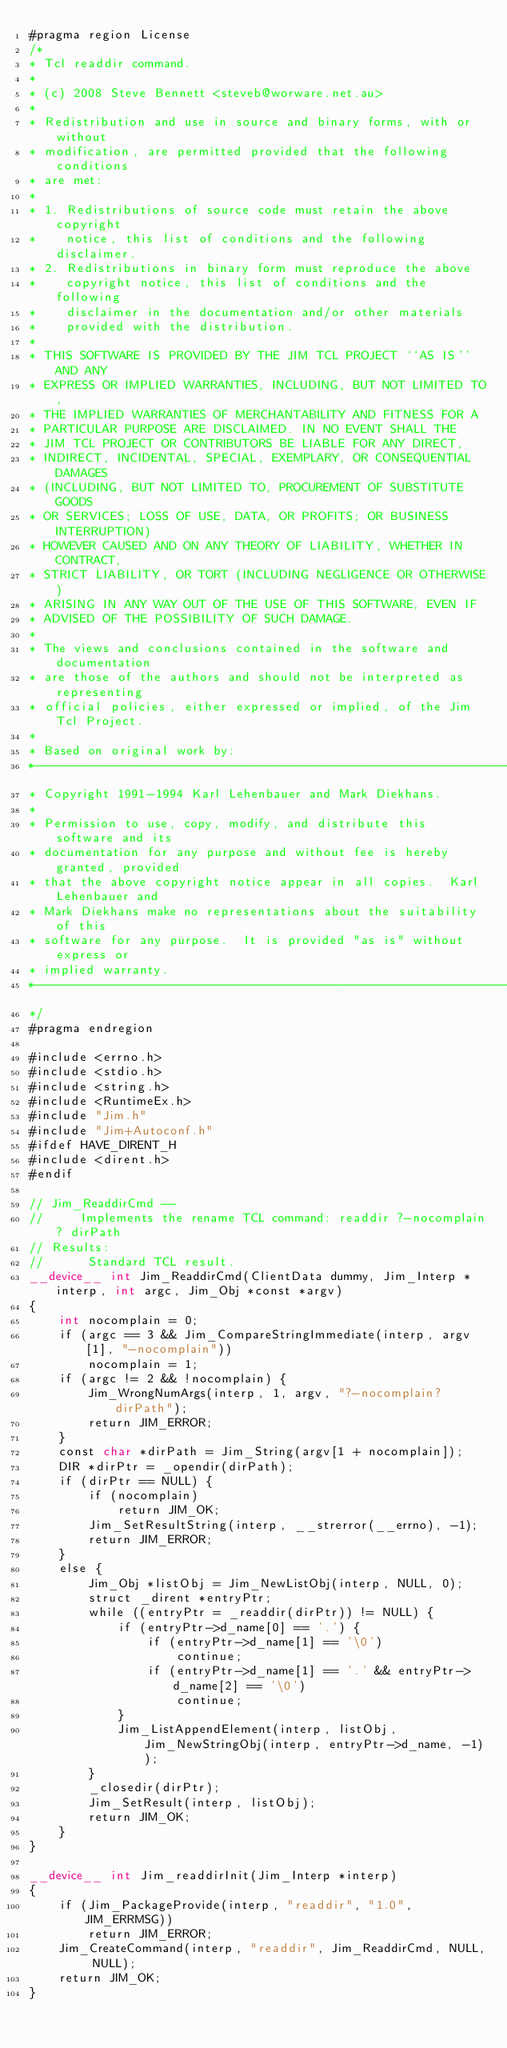Convert code to text. <code><loc_0><loc_0><loc_500><loc_500><_Cuda_>#pragma region License
/*
* Tcl readdir command.
*
* (c) 2008 Steve Bennett <steveb@worware.net.au>
*
* Redistribution and use in source and binary forms, with or without
* modification, are permitted provided that the following conditions
* are met:
*
* 1. Redistributions of source code must retain the above copyright
*    notice, this list of conditions and the following disclaimer.
* 2. Redistributions in binary form must reproduce the above
*    copyright notice, this list of conditions and the following
*    disclaimer in the documentation and/or other materials
*    provided with the distribution.
*
* THIS SOFTWARE IS PROVIDED BY THE JIM TCL PROJECT ``AS IS'' AND ANY
* EXPRESS OR IMPLIED WARRANTIES, INCLUDING, BUT NOT LIMITED TO,
* THE IMPLIED WARRANTIES OF MERCHANTABILITY AND FITNESS FOR A
* PARTICULAR PURPOSE ARE DISCLAIMED. IN NO EVENT SHALL THE
* JIM TCL PROJECT OR CONTRIBUTORS BE LIABLE FOR ANY DIRECT,
* INDIRECT, INCIDENTAL, SPECIAL, EXEMPLARY, OR CONSEQUENTIAL DAMAGES
* (INCLUDING, BUT NOT LIMITED TO, PROCUREMENT OF SUBSTITUTE GOODS
* OR SERVICES; LOSS OF USE, DATA, OR PROFITS; OR BUSINESS INTERRUPTION)
* HOWEVER CAUSED AND ON ANY THEORY OF LIABILITY, WHETHER IN CONTRACT,
* STRICT LIABILITY, OR TORT (INCLUDING NEGLIGENCE OR OTHERWISE)
* ARISING IN ANY WAY OUT OF THE USE OF THIS SOFTWARE, EVEN IF
* ADVISED OF THE POSSIBILITY OF SUCH DAMAGE.
*
* The views and conclusions contained in the software and documentation
* are those of the authors and should not be interpreted as representing
* official policies, either expressed or implied, of the Jim Tcl Project.
*
* Based on original work by:
*-----------------------------------------------------------------------------
* Copyright 1991-1994 Karl Lehenbauer and Mark Diekhans.
*
* Permission to use, copy, modify, and distribute this software and its
* documentation for any purpose and without fee is hereby granted, provided
* that the above copyright notice appear in all copies.  Karl Lehenbauer and
* Mark Diekhans make no representations about the suitability of this
* software for any purpose.  It is provided "as is" without express or
* implied warranty.
*-----------------------------------------------------------------------------
*/
#pragma endregion

#include <errno.h>
#include <stdio.h>
#include <string.h>
#include <RuntimeEx.h>
#include "Jim.h"
#include "Jim+Autoconf.h"
#ifdef HAVE_DIRENT_H
#include <dirent.h>
#endif

// Jim_ReaddirCmd --
//     Implements the rename TCL command: readdir ?-nocomplain? dirPath
// Results:
//      Standard TCL result.
__device__ int Jim_ReaddirCmd(ClientData dummy, Jim_Interp *interp, int argc, Jim_Obj *const *argv)
{
	int nocomplain = 0;
	if (argc == 3 && Jim_CompareStringImmediate(interp, argv[1], "-nocomplain"))
		nocomplain = 1;
	if (argc != 2 && !nocomplain) {
		Jim_WrongNumArgs(interp, 1, argv, "?-nocomplain? dirPath");
		return JIM_ERROR;
	}
	const char *dirPath = Jim_String(argv[1 + nocomplain]);
	DIR *dirPtr = _opendir(dirPath);
	if (dirPtr == NULL) {
		if (nocomplain)
			return JIM_OK;
		Jim_SetResultString(interp, __strerror(__errno), -1);
		return JIM_ERROR;
	}
	else {
		Jim_Obj *listObj = Jim_NewListObj(interp, NULL, 0);
		struct _dirent *entryPtr;
		while ((entryPtr = _readdir(dirPtr)) != NULL) {
			if (entryPtr->d_name[0] == '.') {
				if (entryPtr->d_name[1] == '\0')
					continue;
				if (entryPtr->d_name[1] == '.' && entryPtr->d_name[2] == '\0')
					continue;
			}
			Jim_ListAppendElement(interp, listObj, Jim_NewStringObj(interp, entryPtr->d_name, -1));
		}
		_closedir(dirPtr);
		Jim_SetResult(interp, listObj);
		return JIM_OK;
	}
}

__device__ int Jim_readdirInit(Jim_Interp *interp)
{
	if (Jim_PackageProvide(interp, "readdir", "1.0", JIM_ERRMSG))
		return JIM_ERROR;
	Jim_CreateCommand(interp, "readdir", Jim_ReaddirCmd, NULL, NULL);
	return JIM_OK;
}
</code> 